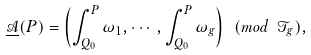Convert formula to latex. <formula><loc_0><loc_0><loc_500><loc_500>\underline { \mathcal { A } } ( P ) = \left ( \int _ { Q _ { 0 } } ^ { P } { \omega _ { 1 } } , \cdots , \int _ { Q _ { 0 } } ^ { P } \omega _ { g } \right ) \ ( m o d \ \mathcal { T } _ { g } ) ,</formula> 